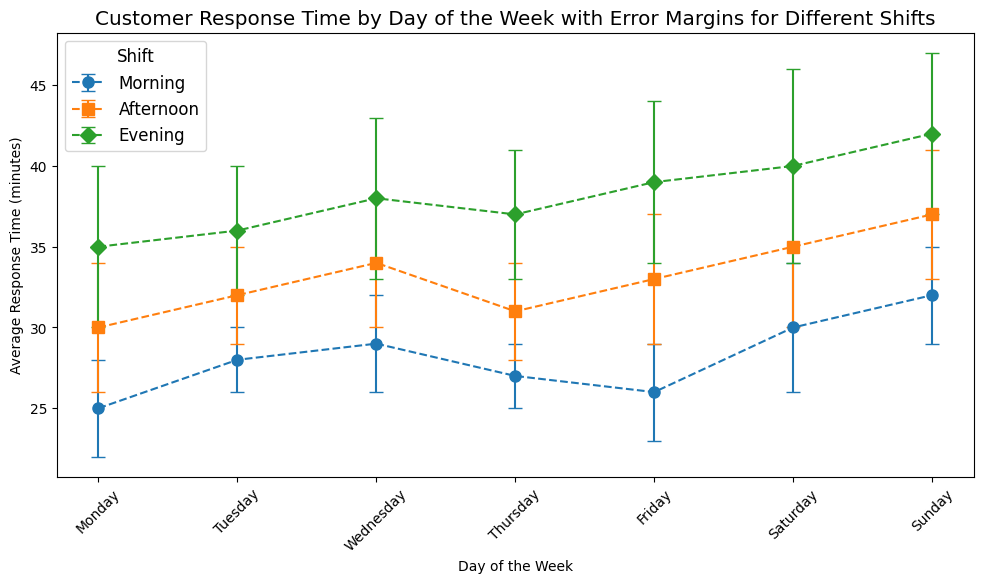What day has the highest average response time for the evening shift? First, look at the evening shift markers, which are diamonds. Identify the highest marker point on the y-axis among the evenings. The evening on Sunday has the highest point at 42 minutes.
Answer: Sunday Which shift has the smallest error margin on Thursday? Find Thursday on the x-axis and locate the error bars for each shift. The shortest error bar corresponds to the morning shift with an error margin of 2.
Answer: Morning How does the average response time on Friday morning compare to Friday evening? Check the markers for Friday morning and evening. Friday morning has an average response time of 26 minutes, while Friday evening has 39 minutes.
Answer: Friday evening is higher What is the average response time difference between Saturday evening and Sunday morning? Locate the average response time markers for both shifts. Saturday evening has 40 minutes and Sunday morning has 32 minutes. The difference is 40 - 32 = 8 minutes.
Answer: 8 minutes Which day has the most consistent response time across all shifts? Consistency can be inferred from the smallest error margins across shifts on a given day. Monday has error margins of 3, 4, and 5, which is fairly consistent but not the smallest. Check other days similarly. Tuesday has error margins of 2, 3, and 4, which are the smallest margins across shifts on any day.
Answer: Tuesday What is the overall trend of average response time over the week during the afternoon shift? Observe the markers corresponding to the afternoon shift through the week. There is a general upward trend starting from Monday at 30 minutes to Sunday at 37 minutes.
Answer: Upward trend Which two consecutive days show the largest increase in average response time for any shift? Calculate the differences in average response times between consecutive days for each shift. The largest difference is between Saturday evening and Sunday evening (40 to 42), 42 - 40 = 2 minutes.
Answer: Saturday to Sunday How much higher is the average response time on Sunday afternoon compared to Monday afternoon? Locate the average response times for both afternoons. Sunday afternoon is at 37 minutes and Monday afternoon is at 30 minutes. 37 - 30 = 7 minutes.
Answer: 7 minutes What color represents the afternoon shift, and how is the data visually identified for this shift? The afternoon shift is identified by looking at the legend, which shows the afternoon shift as orange squares.
Answer: Orange Describe the overall pattern of error margins for the morning shifts throughout the week. Examine the error bars for the morning shift markers. They fluctuate slightly but generally range between 2-4 with most days having an error margin around 3.
Answer: Consistent with minor fluctuations 